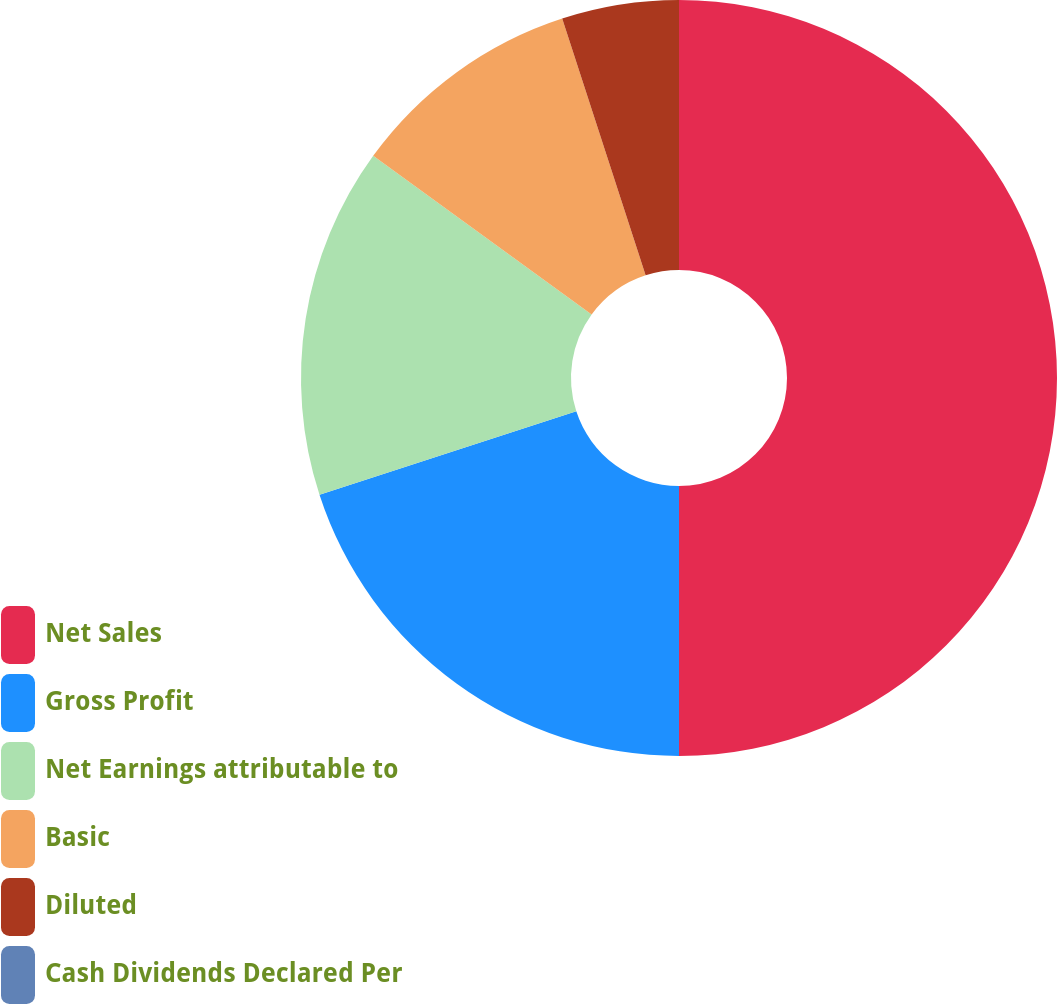Convert chart. <chart><loc_0><loc_0><loc_500><loc_500><pie_chart><fcel>Net Sales<fcel>Gross Profit<fcel>Net Earnings attributable to<fcel>Basic<fcel>Diluted<fcel>Cash Dividends Declared Per<nl><fcel>50.0%<fcel>20.0%<fcel>15.0%<fcel>10.0%<fcel>5.0%<fcel>0.0%<nl></chart> 